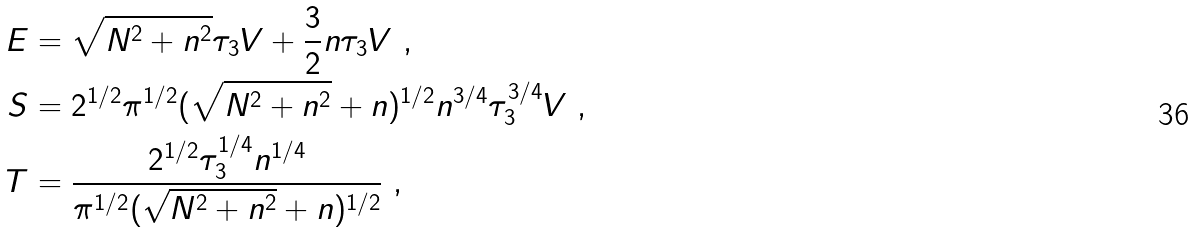<formula> <loc_0><loc_0><loc_500><loc_500>E & = \sqrt { N ^ { 2 } + n ^ { 2 } } \tau _ { 3 } V + \frac { 3 } { 2 } n \tau _ { 3 } V \ , \\ S & = 2 ^ { 1 / 2 } \pi ^ { 1 / 2 } ( \sqrt { N ^ { 2 } + n ^ { 2 } } + n ) ^ { 1 / 2 } n ^ { 3 / 4 } \tau _ { 3 } ^ { 3 / 4 } V \ , \\ T & = \frac { 2 ^ { 1 / 2 } \tau _ { 3 } ^ { 1 / 4 } n ^ { 1 / 4 } } { \pi ^ { 1 / 2 } ( \sqrt { N ^ { 2 } + n ^ { 2 } } + n ) ^ { 1 / 2 } } \ ,</formula> 